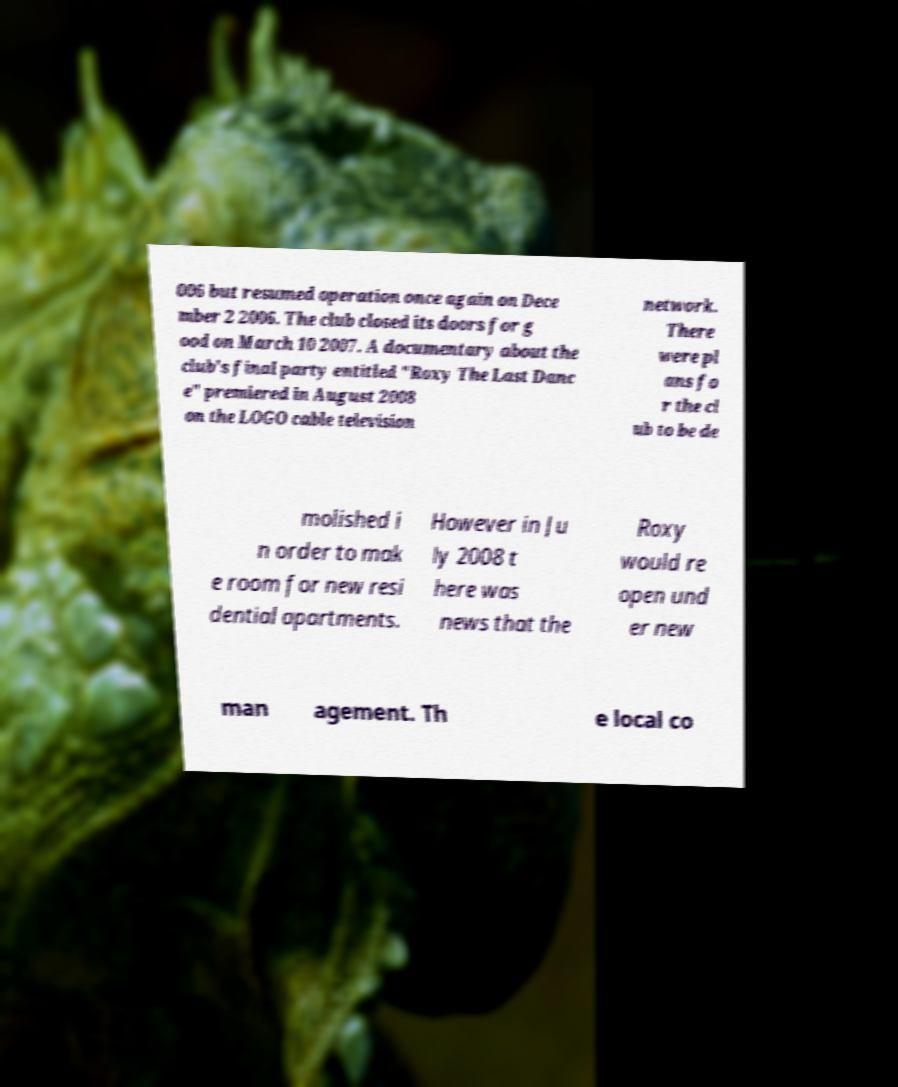Please identify and transcribe the text found in this image. 006 but resumed operation once again on Dece mber 2 2006. The club closed its doors for g ood on March 10 2007. A documentary about the club's final party entitled "Roxy The Last Danc e" premiered in August 2008 on the LOGO cable television network. There were pl ans fo r the cl ub to be de molished i n order to mak e room for new resi dential apartments. However in Ju ly 2008 t here was news that the Roxy would re open und er new man agement. Th e local co 